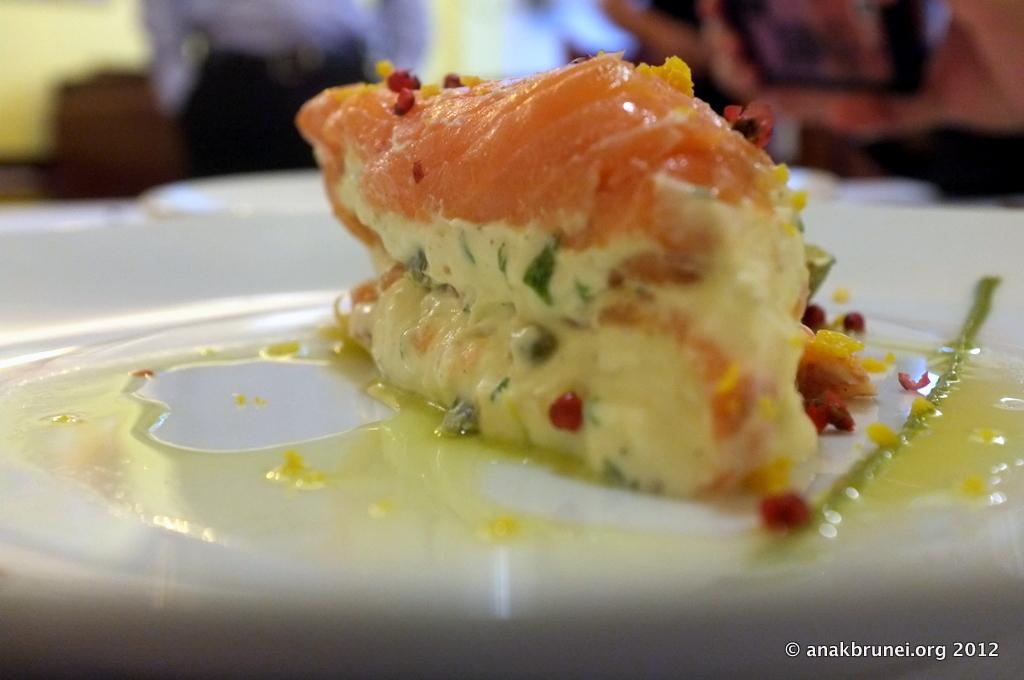What is located at the front of the image? There is a plate in the front of the image. What is on the plate? There is food on the plate. Can you describe the background of the image? The background of the image is blurry. Is there any text visible in the image? Yes, there is some text at the bottom right corner of the image. How many boys are visible in the image, and what type of produce are they holding? There are no boys visible in the image, and no produce is present. 